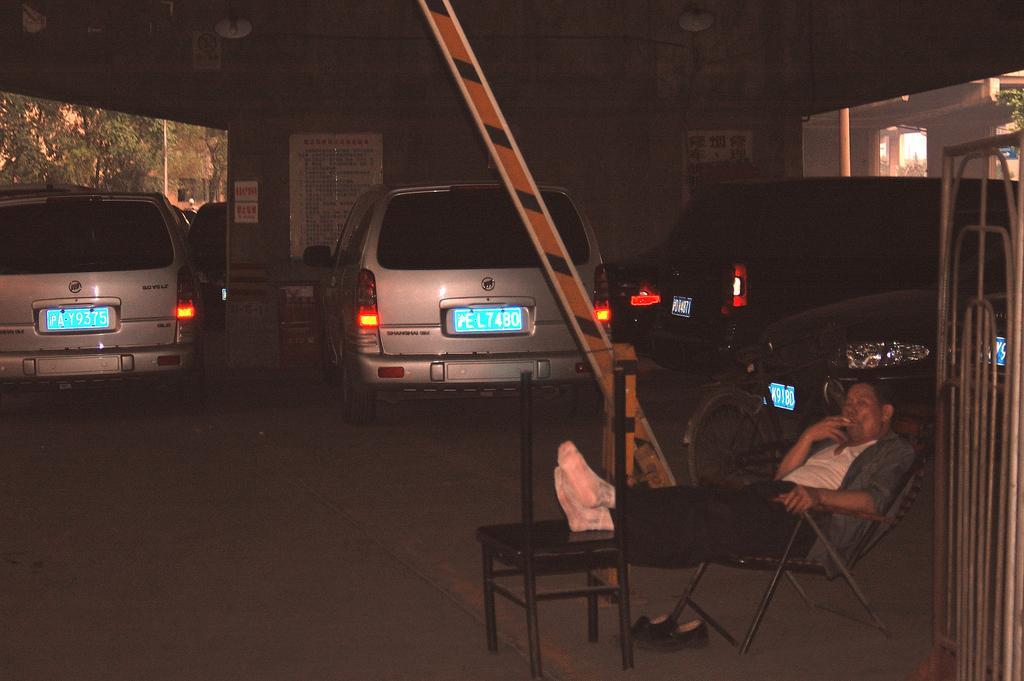In one or two sentences, can you explain what this image depicts? In this image I see a man who is sitting on the chair and he leg are on the chair. In the background I see the cars and the building. 